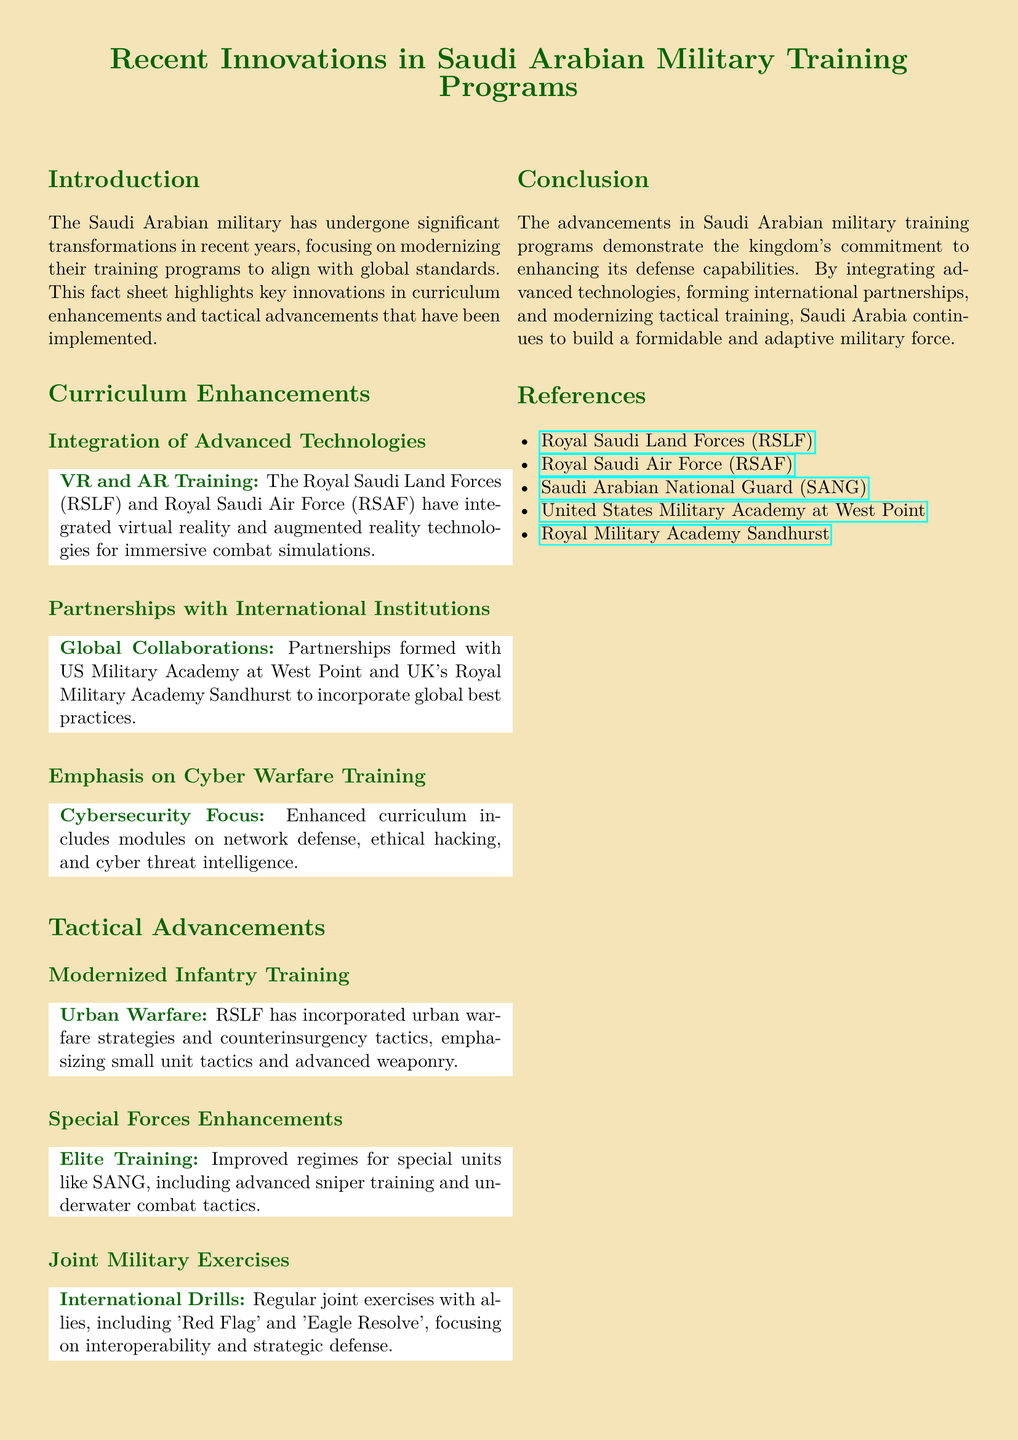What technologies are integrated for training? The document mentions the integration of virtual reality and augmented reality technologies in combat simulations.
Answer: VR and AR Which institutions have partnered with Saudi Arabia? Partnerships are formed with the US Military Academy at West Point and the UK's Royal Military Academy Sandhurst.
Answer: US Military Academy at West Point and UK's Royal Military Academy Sandhurst What is emphasized in the enhanced curriculum? The document highlights that the enhanced curriculum includes modules on network defense, ethical hacking, and cyber threat intelligence.
Answer: Cybersecurity Focus What tactical training has been modernized for infantry? The document states that the RSLF has incorporated urban warfare strategies and counterinsurgency tactics.
Answer: Urban Warfare What type of training is improved for special units? The improved training regimes include advanced sniper training and underwater combat tactics for special units like SANG.
Answer: Elite Training Which exercises focus on interoperability? Regular joint exercises mentioned include 'Red Flag' and 'Eagle Resolve', which focus on interoperability and strategic defense.
Answer: 'Red Flag' and 'Eagle Resolve' 